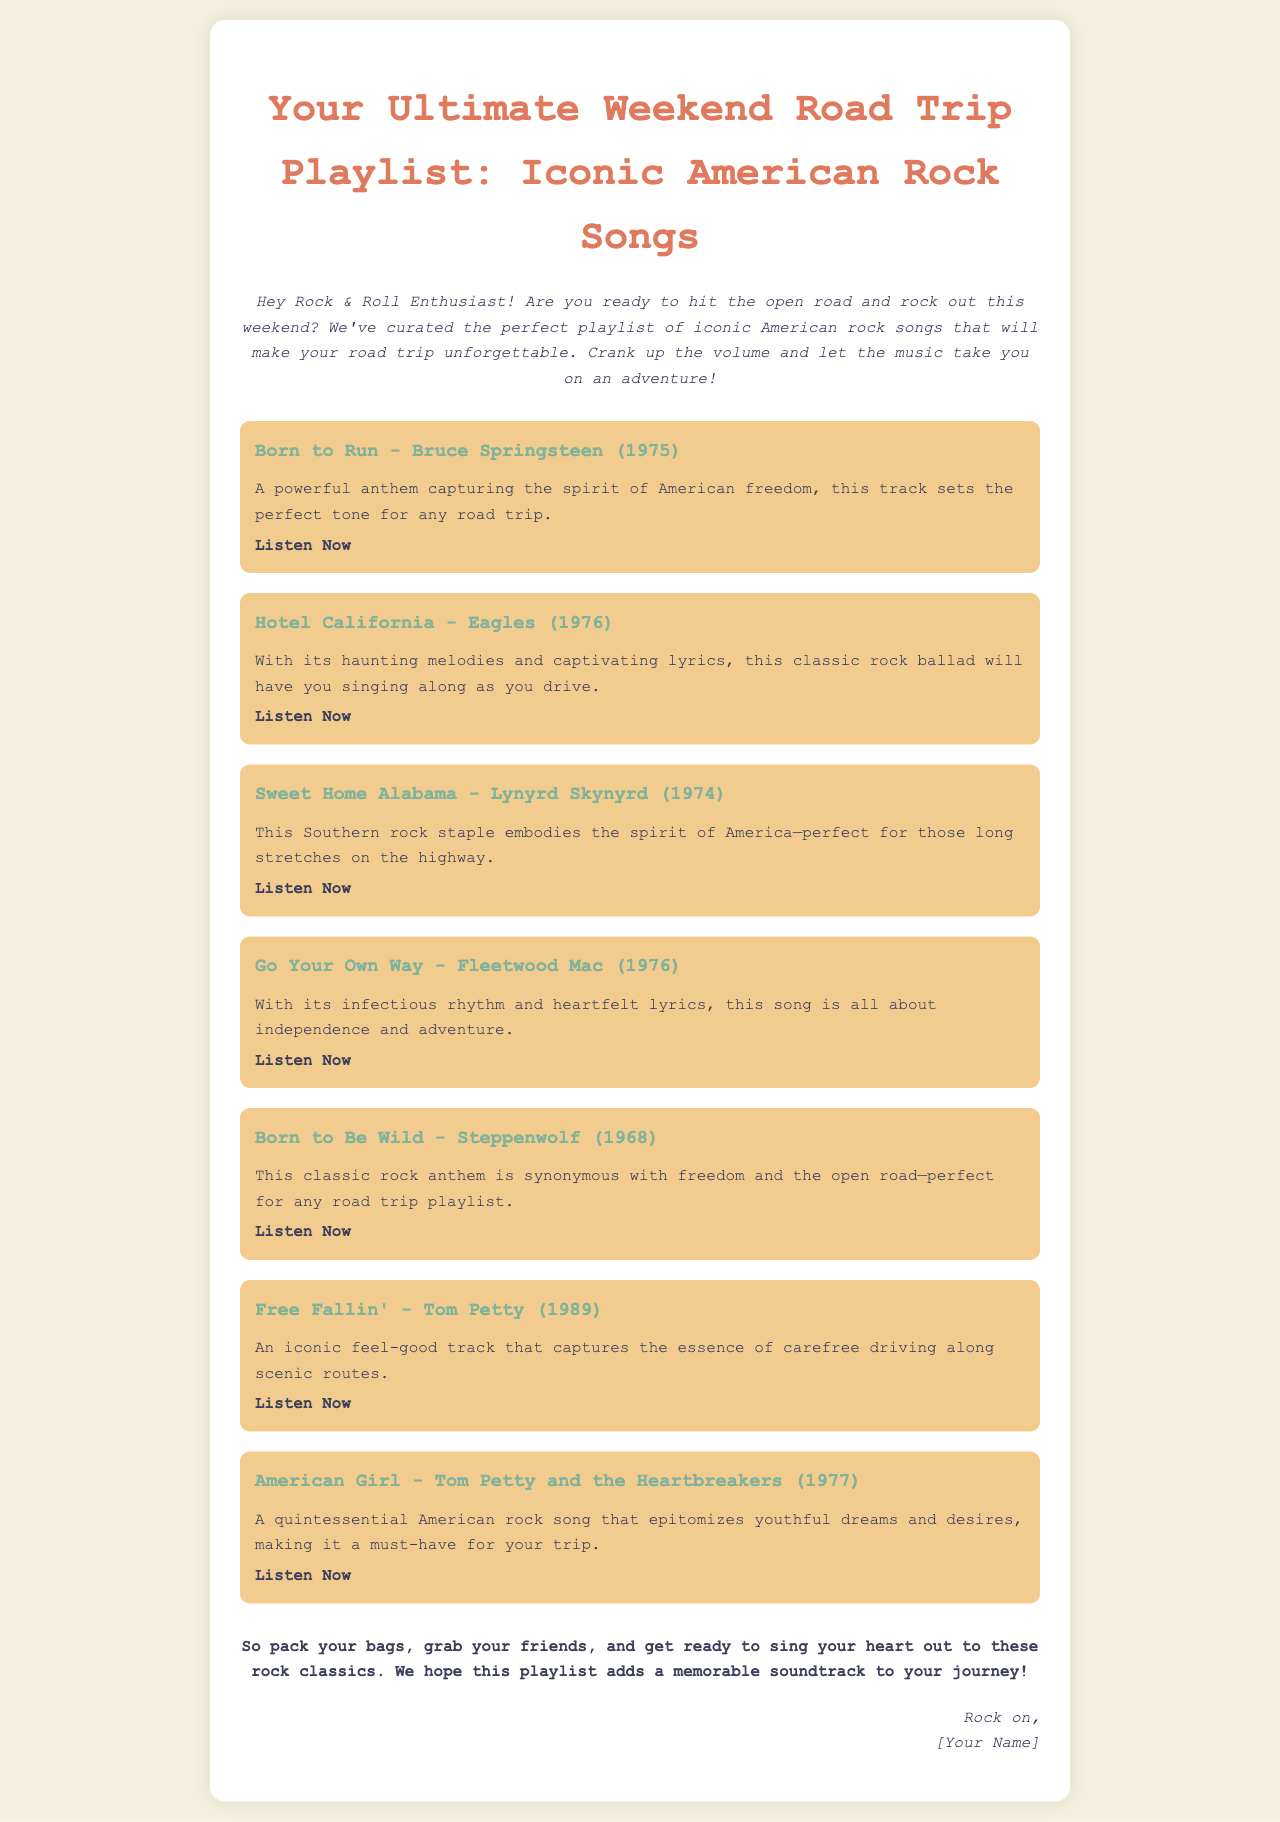What is the title of the playlist? The title of the playlist is prominently displayed at the top of the document.
Answer: Your Ultimate Weekend Road Trip Playlist: Iconic American Rock Songs Who is the artist of the song "Sweet Home Alabama"? The document lists the song along with its artist.
Answer: Lynyrd Skynyrd What year was "Born to Run" released? The release year is included in parentheses next to the song title.
Answer: 1975 How many songs are included in the playlist? The total number of songs can be counted from the list.
Answer: 7 What is the theme of the playlist? The theme is summarized in the introductory paragraph.
Answer: Iconic American rock songs Which song is associated with freedom and the open road? The document describes a specific song as synonymous with this theme.
Answer: Born to Be Wild What style of document is this? The structure and purpose of the document indicate this type.
Answer: Email What does the closing encourage the reader to do? The closing paragraph suggests a specific action for the reader.
Answer: Sing your heart out to these rock classics 